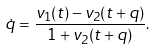Convert formula to latex. <formula><loc_0><loc_0><loc_500><loc_500>\dot { q } = \frac { v _ { 1 } ( t ) - v _ { 2 } ( t + q ) } { 1 + v _ { 2 } ( t + q ) } .</formula> 